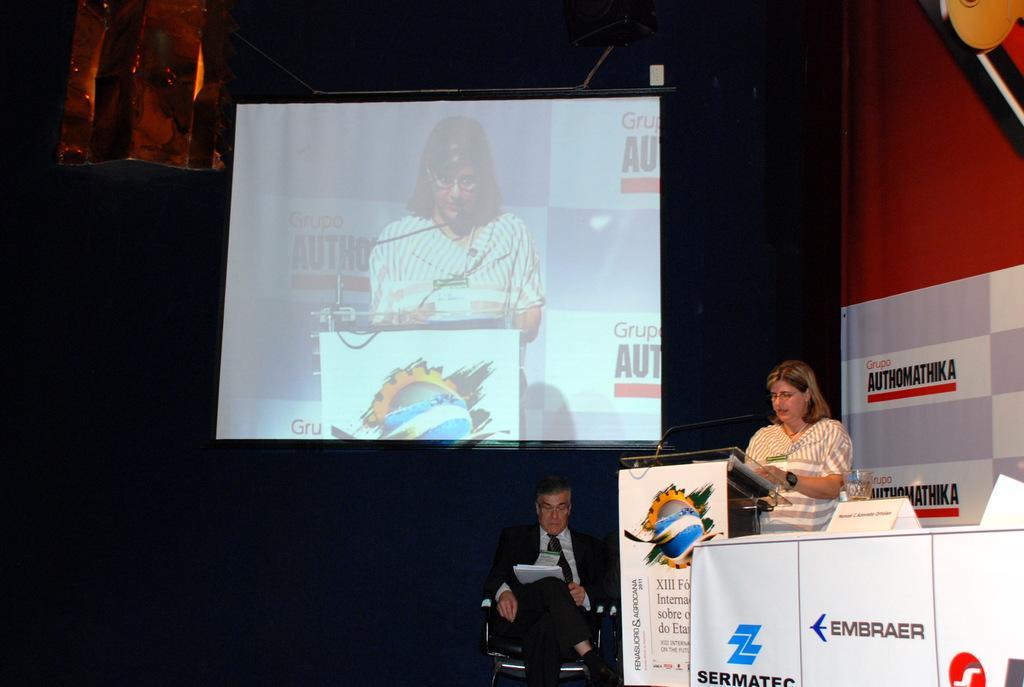Can you describe this image briefly? In this image there are persons sitting and standing. The man in the center is sitting on a chair and is looking at the papers which is on his lap. On the right side there is a woman standing. In front of the woman there is a podium and a mic and there are banners with some text written on it. In the center, on the top there is a screen and in the background there is a blue colour curtain. 